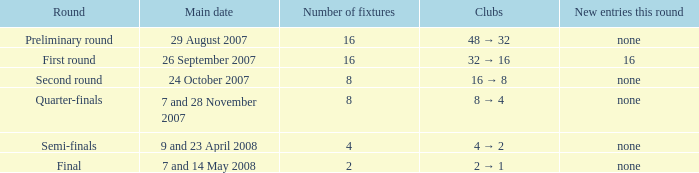When there are 4 fixtures, what is the clubs? 4 → 2. 